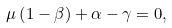<formula> <loc_0><loc_0><loc_500><loc_500>\mu \left ( 1 - \beta \right ) + \alpha - \gamma = 0 ,</formula> 